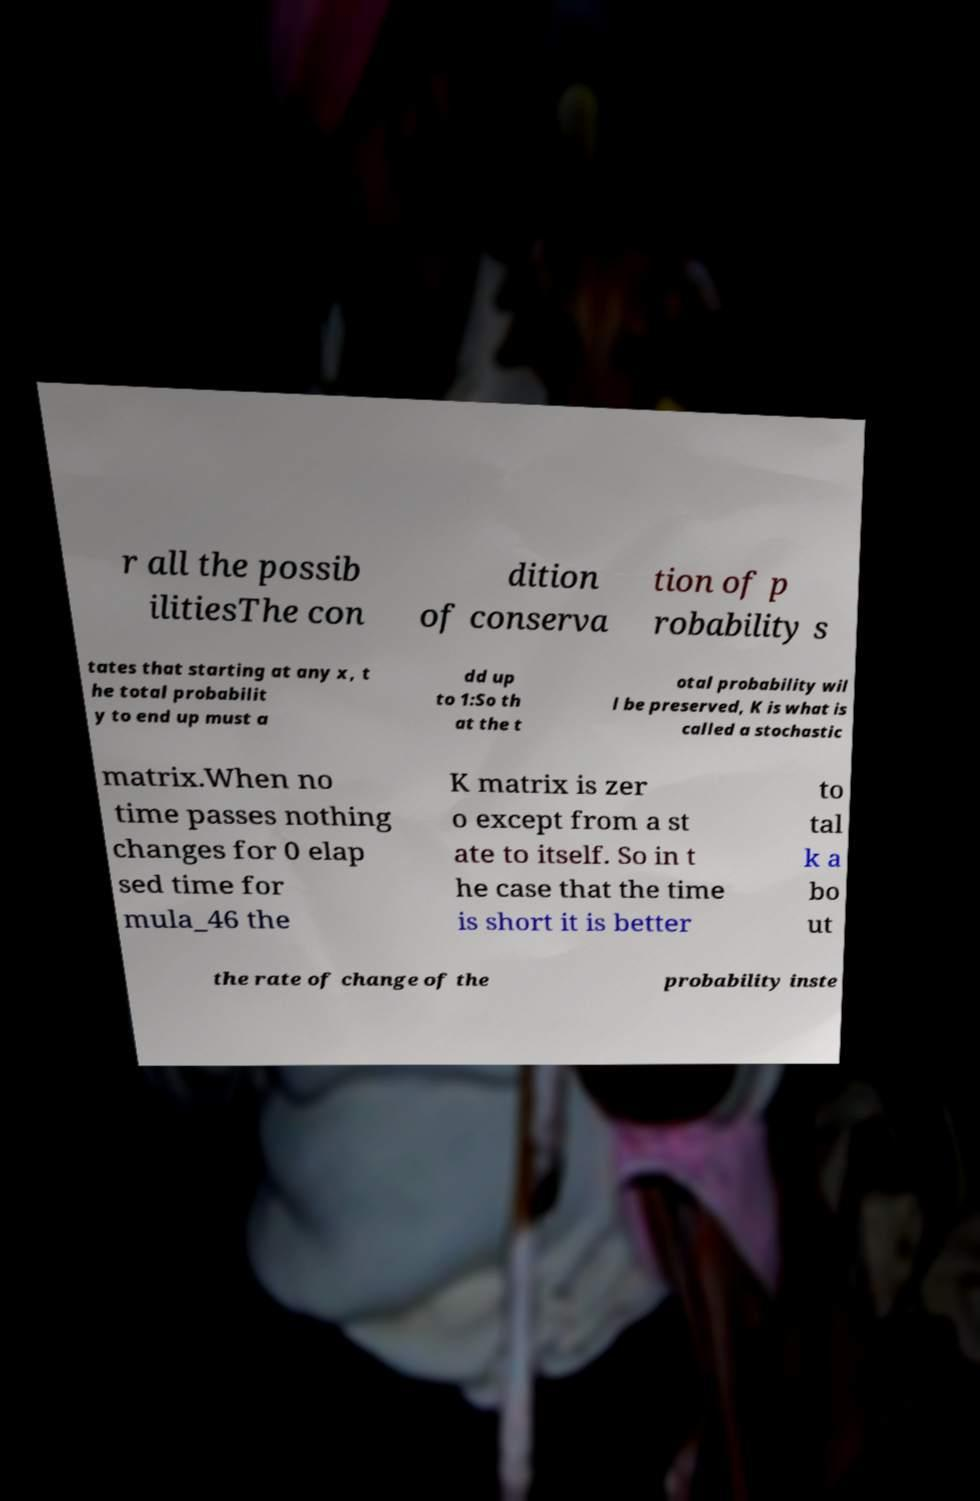Please read and relay the text visible in this image. What does it say? r all the possib ilitiesThe con dition of conserva tion of p robability s tates that starting at any x, t he total probabilit y to end up must a dd up to 1:So th at the t otal probability wil l be preserved, K is what is called a stochastic matrix.When no time passes nothing changes for 0 elap sed time for mula_46 the K matrix is zer o except from a st ate to itself. So in t he case that the time is short it is better to tal k a bo ut the rate of change of the probability inste 